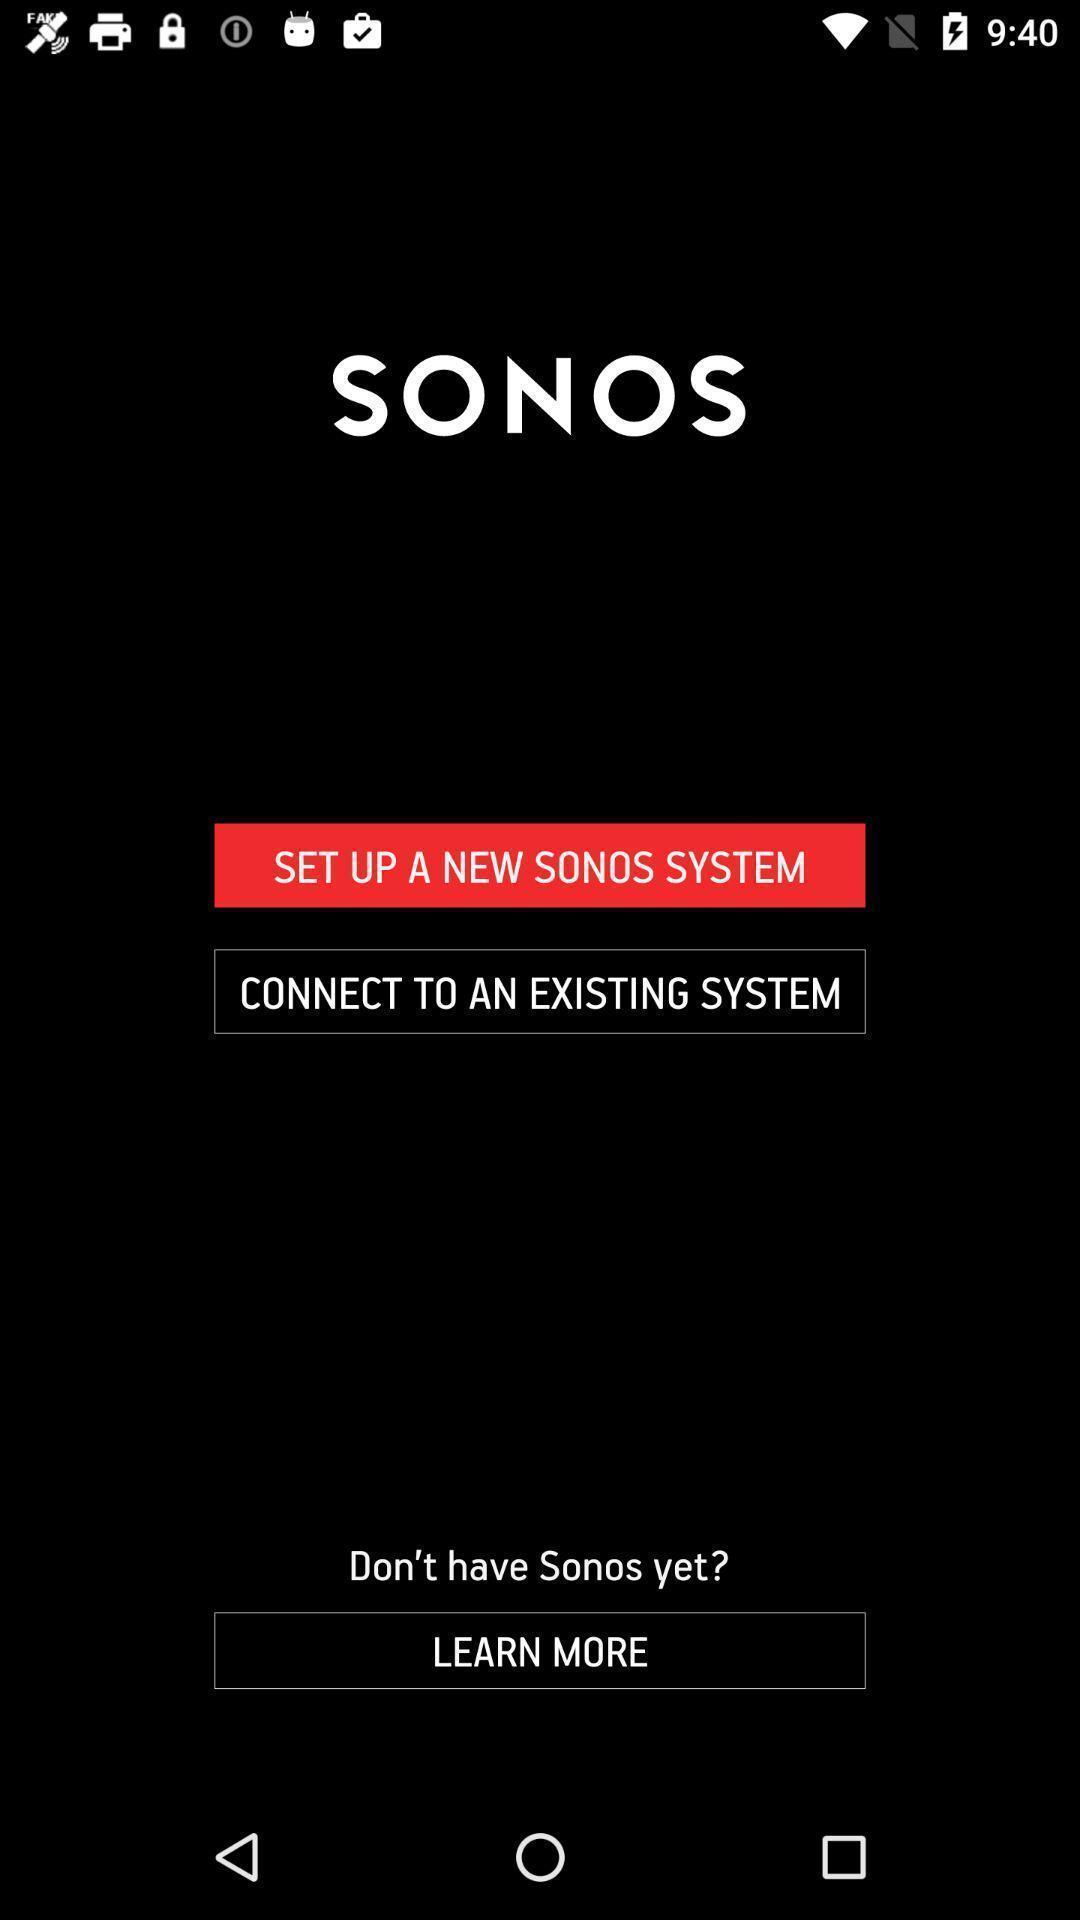Describe this image in words. Welcome page of a sound system app. 